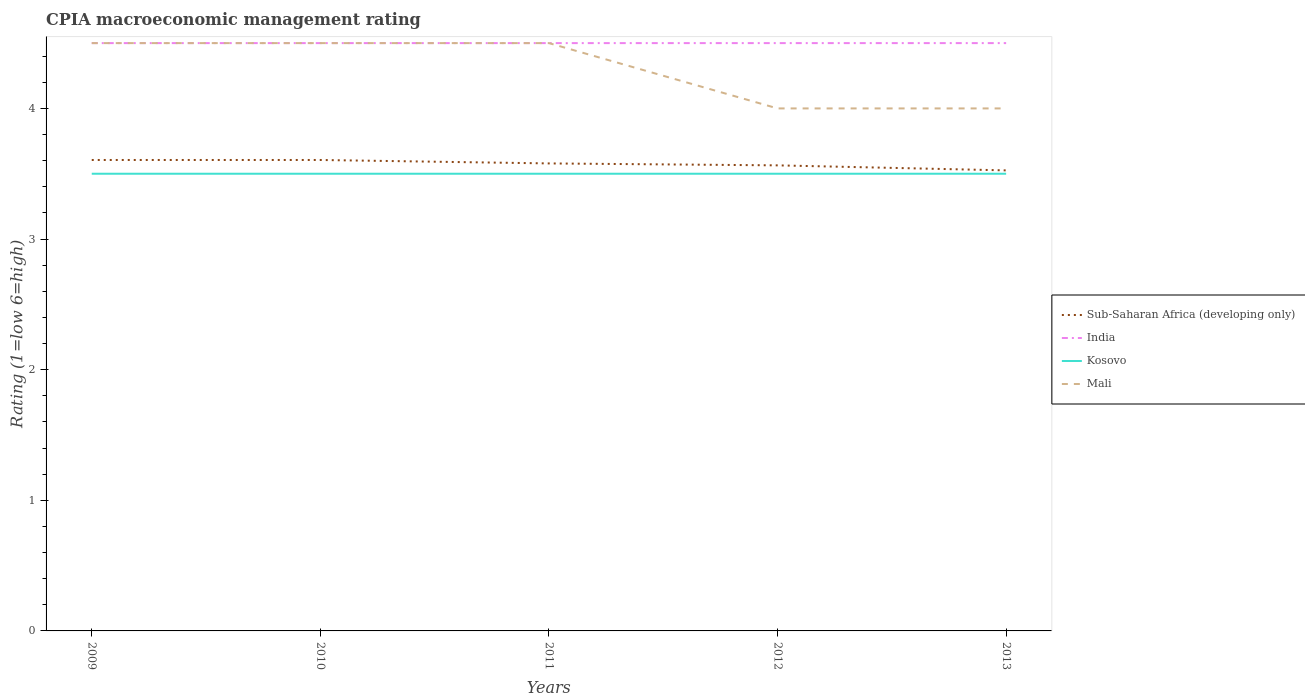Does the line corresponding to Kosovo intersect with the line corresponding to Sub-Saharan Africa (developing only)?
Your answer should be very brief. No. What is the difference between the highest and the lowest CPIA rating in Mali?
Your response must be concise. 3. What is the difference between two consecutive major ticks on the Y-axis?
Your answer should be very brief. 1. Are the values on the major ticks of Y-axis written in scientific E-notation?
Ensure brevity in your answer.  No. Does the graph contain grids?
Offer a terse response. No. What is the title of the graph?
Give a very brief answer. CPIA macroeconomic management rating. Does "Bahrain" appear as one of the legend labels in the graph?
Offer a very short reply. No. What is the Rating (1=low 6=high) of Sub-Saharan Africa (developing only) in 2009?
Offer a terse response. 3.61. What is the Rating (1=low 6=high) in Sub-Saharan Africa (developing only) in 2010?
Keep it short and to the point. 3.61. What is the Rating (1=low 6=high) in India in 2010?
Your answer should be compact. 4.5. What is the Rating (1=low 6=high) in Kosovo in 2010?
Offer a very short reply. 3.5. What is the Rating (1=low 6=high) of Mali in 2010?
Give a very brief answer. 4.5. What is the Rating (1=low 6=high) of Sub-Saharan Africa (developing only) in 2011?
Provide a short and direct response. 3.58. What is the Rating (1=low 6=high) of India in 2011?
Make the answer very short. 4.5. What is the Rating (1=low 6=high) in Kosovo in 2011?
Offer a terse response. 3.5. What is the Rating (1=low 6=high) in Sub-Saharan Africa (developing only) in 2012?
Your answer should be compact. 3.56. What is the Rating (1=low 6=high) in India in 2012?
Your answer should be compact. 4.5. What is the Rating (1=low 6=high) in Kosovo in 2012?
Keep it short and to the point. 3.5. What is the Rating (1=low 6=high) of Sub-Saharan Africa (developing only) in 2013?
Make the answer very short. 3.53. What is the Rating (1=low 6=high) of India in 2013?
Provide a short and direct response. 4.5. What is the Rating (1=low 6=high) in Mali in 2013?
Provide a succinct answer. 4. Across all years, what is the maximum Rating (1=low 6=high) in Sub-Saharan Africa (developing only)?
Offer a terse response. 3.61. Across all years, what is the minimum Rating (1=low 6=high) in Sub-Saharan Africa (developing only)?
Keep it short and to the point. 3.53. Across all years, what is the minimum Rating (1=low 6=high) in Kosovo?
Make the answer very short. 3.5. Across all years, what is the minimum Rating (1=low 6=high) of Mali?
Keep it short and to the point. 4. What is the total Rating (1=low 6=high) of Sub-Saharan Africa (developing only) in the graph?
Ensure brevity in your answer.  17.88. What is the total Rating (1=low 6=high) in India in the graph?
Your response must be concise. 22.5. What is the total Rating (1=low 6=high) of Mali in the graph?
Keep it short and to the point. 21.5. What is the difference between the Rating (1=low 6=high) in Kosovo in 2009 and that in 2010?
Your answer should be compact. 0. What is the difference between the Rating (1=low 6=high) of Sub-Saharan Africa (developing only) in 2009 and that in 2011?
Provide a succinct answer. 0.03. What is the difference between the Rating (1=low 6=high) of Kosovo in 2009 and that in 2011?
Offer a terse response. 0. What is the difference between the Rating (1=low 6=high) in Mali in 2009 and that in 2011?
Keep it short and to the point. 0. What is the difference between the Rating (1=low 6=high) in Sub-Saharan Africa (developing only) in 2009 and that in 2012?
Give a very brief answer. 0.04. What is the difference between the Rating (1=low 6=high) in Kosovo in 2009 and that in 2012?
Ensure brevity in your answer.  0. What is the difference between the Rating (1=low 6=high) of Sub-Saharan Africa (developing only) in 2009 and that in 2013?
Your answer should be very brief. 0.08. What is the difference between the Rating (1=low 6=high) of Mali in 2009 and that in 2013?
Make the answer very short. 0.5. What is the difference between the Rating (1=low 6=high) of Sub-Saharan Africa (developing only) in 2010 and that in 2011?
Provide a short and direct response. 0.03. What is the difference between the Rating (1=low 6=high) in India in 2010 and that in 2011?
Your answer should be very brief. 0. What is the difference between the Rating (1=low 6=high) of Kosovo in 2010 and that in 2011?
Keep it short and to the point. 0. What is the difference between the Rating (1=low 6=high) in Sub-Saharan Africa (developing only) in 2010 and that in 2012?
Offer a very short reply. 0.04. What is the difference between the Rating (1=low 6=high) of Kosovo in 2010 and that in 2012?
Your response must be concise. 0. What is the difference between the Rating (1=low 6=high) of Sub-Saharan Africa (developing only) in 2010 and that in 2013?
Provide a succinct answer. 0.08. What is the difference between the Rating (1=low 6=high) of Kosovo in 2010 and that in 2013?
Give a very brief answer. 0. What is the difference between the Rating (1=low 6=high) in Mali in 2010 and that in 2013?
Your answer should be very brief. 0.5. What is the difference between the Rating (1=low 6=high) of Sub-Saharan Africa (developing only) in 2011 and that in 2012?
Keep it short and to the point. 0.01. What is the difference between the Rating (1=low 6=high) of India in 2011 and that in 2012?
Make the answer very short. 0. What is the difference between the Rating (1=low 6=high) in Mali in 2011 and that in 2012?
Give a very brief answer. 0.5. What is the difference between the Rating (1=low 6=high) of Sub-Saharan Africa (developing only) in 2011 and that in 2013?
Keep it short and to the point. 0.05. What is the difference between the Rating (1=low 6=high) of India in 2011 and that in 2013?
Provide a short and direct response. 0. What is the difference between the Rating (1=low 6=high) in Sub-Saharan Africa (developing only) in 2012 and that in 2013?
Your response must be concise. 0.04. What is the difference between the Rating (1=low 6=high) in Kosovo in 2012 and that in 2013?
Your answer should be compact. 0. What is the difference between the Rating (1=low 6=high) in Mali in 2012 and that in 2013?
Your answer should be very brief. 0. What is the difference between the Rating (1=low 6=high) in Sub-Saharan Africa (developing only) in 2009 and the Rating (1=low 6=high) in India in 2010?
Your answer should be very brief. -0.89. What is the difference between the Rating (1=low 6=high) in Sub-Saharan Africa (developing only) in 2009 and the Rating (1=low 6=high) in Kosovo in 2010?
Provide a succinct answer. 0.11. What is the difference between the Rating (1=low 6=high) in Sub-Saharan Africa (developing only) in 2009 and the Rating (1=low 6=high) in Mali in 2010?
Offer a terse response. -0.89. What is the difference between the Rating (1=low 6=high) of India in 2009 and the Rating (1=low 6=high) of Kosovo in 2010?
Provide a succinct answer. 1. What is the difference between the Rating (1=low 6=high) in India in 2009 and the Rating (1=low 6=high) in Mali in 2010?
Offer a terse response. 0. What is the difference between the Rating (1=low 6=high) in Kosovo in 2009 and the Rating (1=low 6=high) in Mali in 2010?
Offer a terse response. -1. What is the difference between the Rating (1=low 6=high) of Sub-Saharan Africa (developing only) in 2009 and the Rating (1=low 6=high) of India in 2011?
Your answer should be very brief. -0.89. What is the difference between the Rating (1=low 6=high) of Sub-Saharan Africa (developing only) in 2009 and the Rating (1=low 6=high) of Kosovo in 2011?
Keep it short and to the point. 0.11. What is the difference between the Rating (1=low 6=high) in Sub-Saharan Africa (developing only) in 2009 and the Rating (1=low 6=high) in Mali in 2011?
Your answer should be very brief. -0.89. What is the difference between the Rating (1=low 6=high) of India in 2009 and the Rating (1=low 6=high) of Kosovo in 2011?
Offer a terse response. 1. What is the difference between the Rating (1=low 6=high) in India in 2009 and the Rating (1=low 6=high) in Mali in 2011?
Offer a very short reply. 0. What is the difference between the Rating (1=low 6=high) in Kosovo in 2009 and the Rating (1=low 6=high) in Mali in 2011?
Provide a short and direct response. -1. What is the difference between the Rating (1=low 6=high) in Sub-Saharan Africa (developing only) in 2009 and the Rating (1=low 6=high) in India in 2012?
Make the answer very short. -0.89. What is the difference between the Rating (1=low 6=high) of Sub-Saharan Africa (developing only) in 2009 and the Rating (1=low 6=high) of Kosovo in 2012?
Give a very brief answer. 0.11. What is the difference between the Rating (1=low 6=high) of Sub-Saharan Africa (developing only) in 2009 and the Rating (1=low 6=high) of Mali in 2012?
Give a very brief answer. -0.39. What is the difference between the Rating (1=low 6=high) of India in 2009 and the Rating (1=low 6=high) of Kosovo in 2012?
Give a very brief answer. 1. What is the difference between the Rating (1=low 6=high) of India in 2009 and the Rating (1=low 6=high) of Mali in 2012?
Give a very brief answer. 0.5. What is the difference between the Rating (1=low 6=high) of Sub-Saharan Africa (developing only) in 2009 and the Rating (1=low 6=high) of India in 2013?
Your response must be concise. -0.89. What is the difference between the Rating (1=low 6=high) of Sub-Saharan Africa (developing only) in 2009 and the Rating (1=low 6=high) of Kosovo in 2013?
Provide a succinct answer. 0.11. What is the difference between the Rating (1=low 6=high) of Sub-Saharan Africa (developing only) in 2009 and the Rating (1=low 6=high) of Mali in 2013?
Offer a very short reply. -0.39. What is the difference between the Rating (1=low 6=high) in India in 2009 and the Rating (1=low 6=high) in Kosovo in 2013?
Your response must be concise. 1. What is the difference between the Rating (1=low 6=high) in Kosovo in 2009 and the Rating (1=low 6=high) in Mali in 2013?
Offer a terse response. -0.5. What is the difference between the Rating (1=low 6=high) of Sub-Saharan Africa (developing only) in 2010 and the Rating (1=low 6=high) of India in 2011?
Keep it short and to the point. -0.89. What is the difference between the Rating (1=low 6=high) of Sub-Saharan Africa (developing only) in 2010 and the Rating (1=low 6=high) of Kosovo in 2011?
Offer a very short reply. 0.11. What is the difference between the Rating (1=low 6=high) in Sub-Saharan Africa (developing only) in 2010 and the Rating (1=low 6=high) in Mali in 2011?
Ensure brevity in your answer.  -0.89. What is the difference between the Rating (1=low 6=high) of Sub-Saharan Africa (developing only) in 2010 and the Rating (1=low 6=high) of India in 2012?
Your response must be concise. -0.89. What is the difference between the Rating (1=low 6=high) in Sub-Saharan Africa (developing only) in 2010 and the Rating (1=low 6=high) in Kosovo in 2012?
Give a very brief answer. 0.11. What is the difference between the Rating (1=low 6=high) in Sub-Saharan Africa (developing only) in 2010 and the Rating (1=low 6=high) in Mali in 2012?
Make the answer very short. -0.39. What is the difference between the Rating (1=low 6=high) in India in 2010 and the Rating (1=low 6=high) in Kosovo in 2012?
Provide a short and direct response. 1. What is the difference between the Rating (1=low 6=high) of India in 2010 and the Rating (1=low 6=high) of Mali in 2012?
Provide a short and direct response. 0.5. What is the difference between the Rating (1=low 6=high) of Kosovo in 2010 and the Rating (1=low 6=high) of Mali in 2012?
Give a very brief answer. -0.5. What is the difference between the Rating (1=low 6=high) in Sub-Saharan Africa (developing only) in 2010 and the Rating (1=low 6=high) in India in 2013?
Your answer should be very brief. -0.89. What is the difference between the Rating (1=low 6=high) in Sub-Saharan Africa (developing only) in 2010 and the Rating (1=low 6=high) in Kosovo in 2013?
Your response must be concise. 0.11. What is the difference between the Rating (1=low 6=high) of Sub-Saharan Africa (developing only) in 2010 and the Rating (1=low 6=high) of Mali in 2013?
Make the answer very short. -0.39. What is the difference between the Rating (1=low 6=high) of India in 2010 and the Rating (1=low 6=high) of Kosovo in 2013?
Give a very brief answer. 1. What is the difference between the Rating (1=low 6=high) of India in 2010 and the Rating (1=low 6=high) of Mali in 2013?
Your answer should be compact. 0.5. What is the difference between the Rating (1=low 6=high) of Kosovo in 2010 and the Rating (1=low 6=high) of Mali in 2013?
Provide a succinct answer. -0.5. What is the difference between the Rating (1=low 6=high) of Sub-Saharan Africa (developing only) in 2011 and the Rating (1=low 6=high) of India in 2012?
Give a very brief answer. -0.92. What is the difference between the Rating (1=low 6=high) of Sub-Saharan Africa (developing only) in 2011 and the Rating (1=low 6=high) of Kosovo in 2012?
Provide a succinct answer. 0.08. What is the difference between the Rating (1=low 6=high) in Sub-Saharan Africa (developing only) in 2011 and the Rating (1=low 6=high) in Mali in 2012?
Keep it short and to the point. -0.42. What is the difference between the Rating (1=low 6=high) of India in 2011 and the Rating (1=low 6=high) of Kosovo in 2012?
Keep it short and to the point. 1. What is the difference between the Rating (1=low 6=high) of India in 2011 and the Rating (1=low 6=high) of Mali in 2012?
Offer a terse response. 0.5. What is the difference between the Rating (1=low 6=high) of Sub-Saharan Africa (developing only) in 2011 and the Rating (1=low 6=high) of India in 2013?
Offer a terse response. -0.92. What is the difference between the Rating (1=low 6=high) in Sub-Saharan Africa (developing only) in 2011 and the Rating (1=low 6=high) in Kosovo in 2013?
Provide a short and direct response. 0.08. What is the difference between the Rating (1=low 6=high) in Sub-Saharan Africa (developing only) in 2011 and the Rating (1=low 6=high) in Mali in 2013?
Offer a terse response. -0.42. What is the difference between the Rating (1=low 6=high) in Kosovo in 2011 and the Rating (1=low 6=high) in Mali in 2013?
Your response must be concise. -0.5. What is the difference between the Rating (1=low 6=high) in Sub-Saharan Africa (developing only) in 2012 and the Rating (1=low 6=high) in India in 2013?
Provide a succinct answer. -0.94. What is the difference between the Rating (1=low 6=high) in Sub-Saharan Africa (developing only) in 2012 and the Rating (1=low 6=high) in Kosovo in 2013?
Provide a short and direct response. 0.06. What is the difference between the Rating (1=low 6=high) in Sub-Saharan Africa (developing only) in 2012 and the Rating (1=low 6=high) in Mali in 2013?
Ensure brevity in your answer.  -0.44. What is the difference between the Rating (1=low 6=high) of India in 2012 and the Rating (1=low 6=high) of Kosovo in 2013?
Provide a succinct answer. 1. What is the difference between the Rating (1=low 6=high) of Kosovo in 2012 and the Rating (1=low 6=high) of Mali in 2013?
Provide a short and direct response. -0.5. What is the average Rating (1=low 6=high) of Sub-Saharan Africa (developing only) per year?
Keep it short and to the point. 3.58. What is the average Rating (1=low 6=high) in India per year?
Give a very brief answer. 4.5. What is the average Rating (1=low 6=high) in Mali per year?
Make the answer very short. 4.3. In the year 2009, what is the difference between the Rating (1=low 6=high) in Sub-Saharan Africa (developing only) and Rating (1=low 6=high) in India?
Give a very brief answer. -0.89. In the year 2009, what is the difference between the Rating (1=low 6=high) in Sub-Saharan Africa (developing only) and Rating (1=low 6=high) in Kosovo?
Your answer should be compact. 0.11. In the year 2009, what is the difference between the Rating (1=low 6=high) of Sub-Saharan Africa (developing only) and Rating (1=low 6=high) of Mali?
Keep it short and to the point. -0.89. In the year 2009, what is the difference between the Rating (1=low 6=high) in India and Rating (1=low 6=high) in Mali?
Provide a succinct answer. 0. In the year 2009, what is the difference between the Rating (1=low 6=high) in Kosovo and Rating (1=low 6=high) in Mali?
Provide a short and direct response. -1. In the year 2010, what is the difference between the Rating (1=low 6=high) in Sub-Saharan Africa (developing only) and Rating (1=low 6=high) in India?
Your response must be concise. -0.89. In the year 2010, what is the difference between the Rating (1=low 6=high) in Sub-Saharan Africa (developing only) and Rating (1=low 6=high) in Kosovo?
Provide a short and direct response. 0.11. In the year 2010, what is the difference between the Rating (1=low 6=high) of Sub-Saharan Africa (developing only) and Rating (1=low 6=high) of Mali?
Provide a short and direct response. -0.89. In the year 2010, what is the difference between the Rating (1=low 6=high) in India and Rating (1=low 6=high) in Mali?
Ensure brevity in your answer.  0. In the year 2011, what is the difference between the Rating (1=low 6=high) of Sub-Saharan Africa (developing only) and Rating (1=low 6=high) of India?
Offer a very short reply. -0.92. In the year 2011, what is the difference between the Rating (1=low 6=high) of Sub-Saharan Africa (developing only) and Rating (1=low 6=high) of Kosovo?
Provide a short and direct response. 0.08. In the year 2011, what is the difference between the Rating (1=low 6=high) in Sub-Saharan Africa (developing only) and Rating (1=low 6=high) in Mali?
Keep it short and to the point. -0.92. In the year 2012, what is the difference between the Rating (1=low 6=high) of Sub-Saharan Africa (developing only) and Rating (1=low 6=high) of India?
Ensure brevity in your answer.  -0.94. In the year 2012, what is the difference between the Rating (1=low 6=high) of Sub-Saharan Africa (developing only) and Rating (1=low 6=high) of Kosovo?
Ensure brevity in your answer.  0.06. In the year 2012, what is the difference between the Rating (1=low 6=high) of Sub-Saharan Africa (developing only) and Rating (1=low 6=high) of Mali?
Make the answer very short. -0.44. In the year 2012, what is the difference between the Rating (1=low 6=high) in India and Rating (1=low 6=high) in Kosovo?
Offer a terse response. 1. In the year 2012, what is the difference between the Rating (1=low 6=high) of India and Rating (1=low 6=high) of Mali?
Ensure brevity in your answer.  0.5. In the year 2012, what is the difference between the Rating (1=low 6=high) of Kosovo and Rating (1=low 6=high) of Mali?
Your answer should be very brief. -0.5. In the year 2013, what is the difference between the Rating (1=low 6=high) in Sub-Saharan Africa (developing only) and Rating (1=low 6=high) in India?
Give a very brief answer. -0.97. In the year 2013, what is the difference between the Rating (1=low 6=high) of Sub-Saharan Africa (developing only) and Rating (1=low 6=high) of Kosovo?
Keep it short and to the point. 0.03. In the year 2013, what is the difference between the Rating (1=low 6=high) in Sub-Saharan Africa (developing only) and Rating (1=low 6=high) in Mali?
Make the answer very short. -0.47. What is the ratio of the Rating (1=low 6=high) in Sub-Saharan Africa (developing only) in 2009 to that in 2010?
Provide a succinct answer. 1. What is the ratio of the Rating (1=low 6=high) of Mali in 2009 to that in 2010?
Your answer should be compact. 1. What is the ratio of the Rating (1=low 6=high) of Sub-Saharan Africa (developing only) in 2009 to that in 2011?
Provide a succinct answer. 1.01. What is the ratio of the Rating (1=low 6=high) in Kosovo in 2009 to that in 2011?
Provide a succinct answer. 1. What is the ratio of the Rating (1=low 6=high) of Sub-Saharan Africa (developing only) in 2009 to that in 2012?
Your response must be concise. 1.01. What is the ratio of the Rating (1=low 6=high) of India in 2009 to that in 2012?
Provide a short and direct response. 1. What is the ratio of the Rating (1=low 6=high) of Sub-Saharan Africa (developing only) in 2009 to that in 2013?
Your response must be concise. 1.02. What is the ratio of the Rating (1=low 6=high) in India in 2009 to that in 2013?
Ensure brevity in your answer.  1. What is the ratio of the Rating (1=low 6=high) in Kosovo in 2009 to that in 2013?
Offer a very short reply. 1. What is the ratio of the Rating (1=low 6=high) in Mali in 2009 to that in 2013?
Your answer should be very brief. 1.12. What is the ratio of the Rating (1=low 6=high) of Sub-Saharan Africa (developing only) in 2010 to that in 2011?
Provide a succinct answer. 1.01. What is the ratio of the Rating (1=low 6=high) of Kosovo in 2010 to that in 2011?
Give a very brief answer. 1. What is the ratio of the Rating (1=low 6=high) in Mali in 2010 to that in 2011?
Provide a succinct answer. 1. What is the ratio of the Rating (1=low 6=high) of Sub-Saharan Africa (developing only) in 2010 to that in 2012?
Offer a very short reply. 1.01. What is the ratio of the Rating (1=low 6=high) of India in 2010 to that in 2012?
Offer a very short reply. 1. What is the ratio of the Rating (1=low 6=high) in Kosovo in 2010 to that in 2012?
Offer a terse response. 1. What is the ratio of the Rating (1=low 6=high) in Mali in 2010 to that in 2012?
Provide a short and direct response. 1.12. What is the ratio of the Rating (1=low 6=high) in Sub-Saharan Africa (developing only) in 2010 to that in 2013?
Your answer should be very brief. 1.02. What is the ratio of the Rating (1=low 6=high) of Kosovo in 2010 to that in 2013?
Provide a succinct answer. 1. What is the ratio of the Rating (1=low 6=high) of Mali in 2010 to that in 2013?
Keep it short and to the point. 1.12. What is the ratio of the Rating (1=low 6=high) of Kosovo in 2011 to that in 2012?
Ensure brevity in your answer.  1. What is the ratio of the Rating (1=low 6=high) of Mali in 2011 to that in 2012?
Offer a very short reply. 1.12. What is the ratio of the Rating (1=low 6=high) in Sub-Saharan Africa (developing only) in 2011 to that in 2013?
Offer a very short reply. 1.02. What is the ratio of the Rating (1=low 6=high) in India in 2011 to that in 2013?
Give a very brief answer. 1. What is the ratio of the Rating (1=low 6=high) of Mali in 2011 to that in 2013?
Provide a short and direct response. 1.12. What is the ratio of the Rating (1=low 6=high) of Sub-Saharan Africa (developing only) in 2012 to that in 2013?
Offer a terse response. 1.01. What is the ratio of the Rating (1=low 6=high) in India in 2012 to that in 2013?
Make the answer very short. 1. What is the ratio of the Rating (1=low 6=high) of Kosovo in 2012 to that in 2013?
Keep it short and to the point. 1. What is the ratio of the Rating (1=low 6=high) in Mali in 2012 to that in 2013?
Your answer should be compact. 1. What is the difference between the highest and the second highest Rating (1=low 6=high) of Sub-Saharan Africa (developing only)?
Make the answer very short. 0. What is the difference between the highest and the second highest Rating (1=low 6=high) of India?
Your answer should be very brief. 0. What is the difference between the highest and the second highest Rating (1=low 6=high) of Kosovo?
Provide a short and direct response. 0. What is the difference between the highest and the second highest Rating (1=low 6=high) in Mali?
Your answer should be compact. 0. What is the difference between the highest and the lowest Rating (1=low 6=high) in Sub-Saharan Africa (developing only)?
Ensure brevity in your answer.  0.08. What is the difference between the highest and the lowest Rating (1=low 6=high) of Kosovo?
Offer a very short reply. 0. 